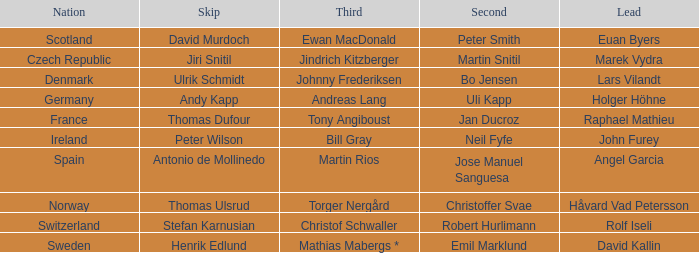Which Lead has a Nation of switzerland? Rolf Iseli. 